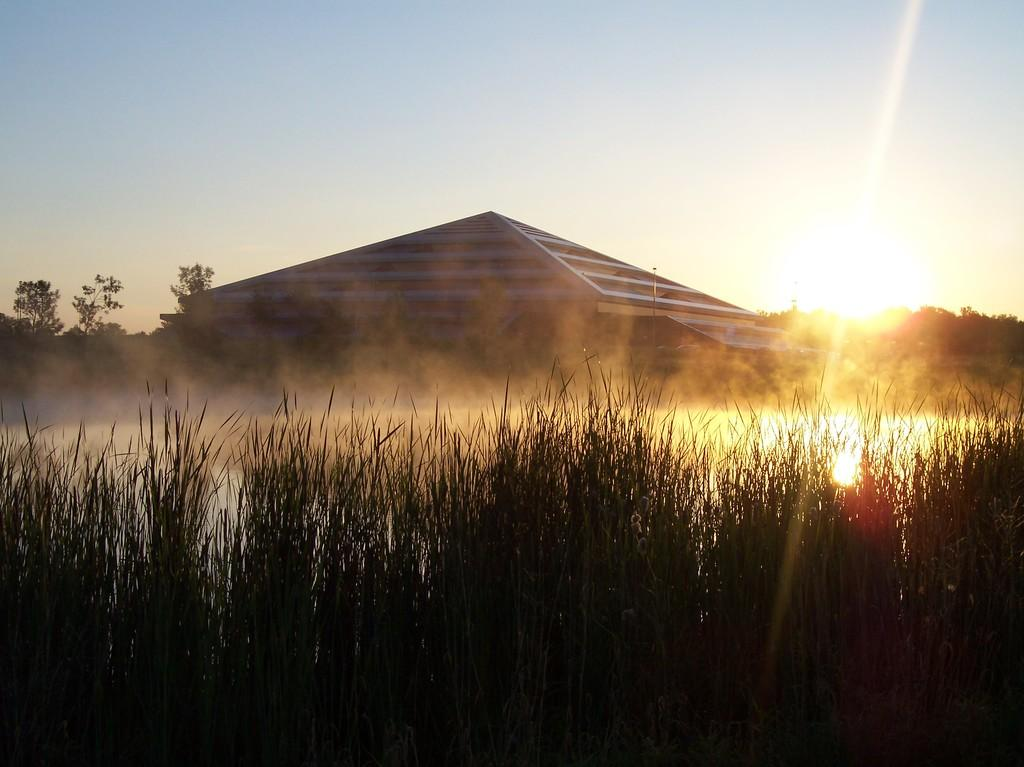What is the main structure in the center of the image? There is a building in the center of the image. What can be seen at the bottom of the image? Water and plants are visible at the bottom of the image. What type of vegetation is in the background of the image? There are trees in the background of the image. What else is visible in the background of the image? The sky is visible in the background of the image. What type of brush is being used to paint the line in the image? There is no brush or line present in the image; it features a building, water, plants, trees, and the sky. 